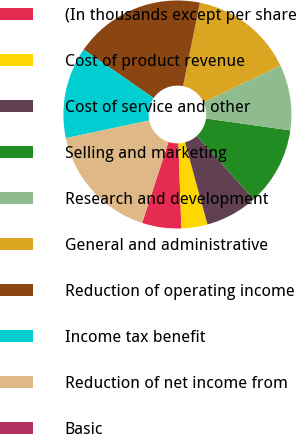Convert chart. <chart><loc_0><loc_0><loc_500><loc_500><pie_chart><fcel>(In thousands except per share<fcel>Cost of product revenue<fcel>Cost of service and other<fcel>Selling and marketing<fcel>Research and development<fcel>General and administrative<fcel>Reduction of operating income<fcel>Income tax benefit<fcel>Reduction of net income from<fcel>Basic<nl><fcel>5.56%<fcel>3.7%<fcel>7.41%<fcel>11.11%<fcel>9.26%<fcel>14.81%<fcel>18.52%<fcel>12.96%<fcel>16.67%<fcel>0.0%<nl></chart> 